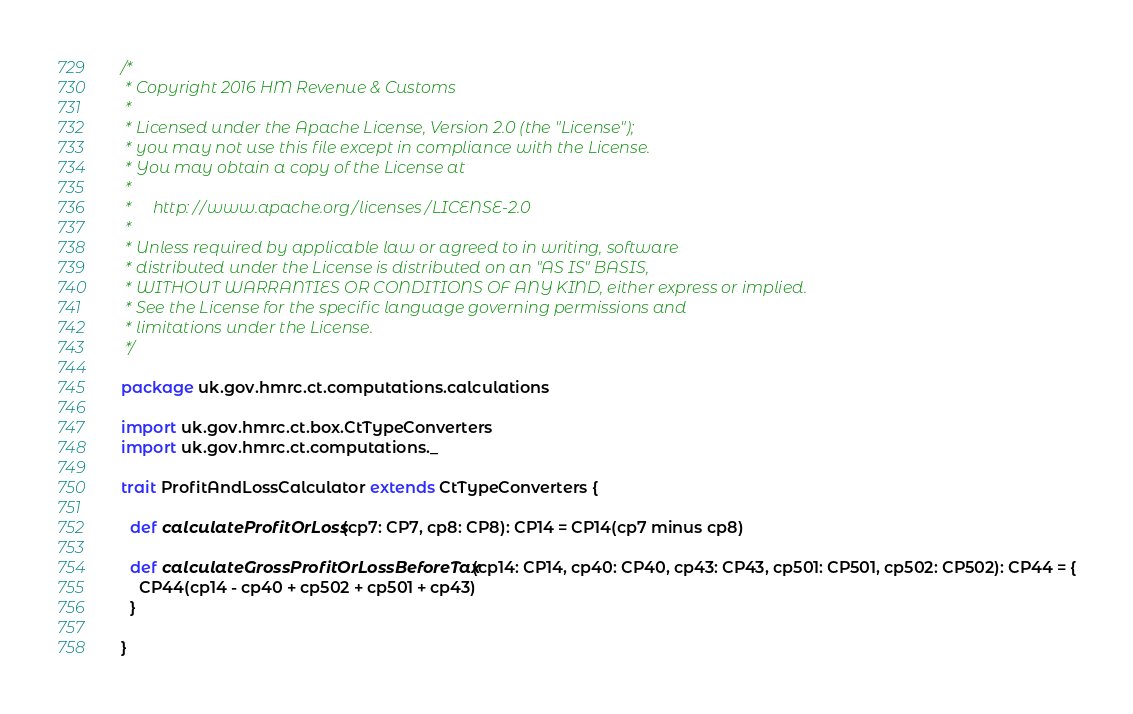<code> <loc_0><loc_0><loc_500><loc_500><_Scala_>/*
 * Copyright 2016 HM Revenue & Customs
 *
 * Licensed under the Apache License, Version 2.0 (the "License");
 * you may not use this file except in compliance with the License.
 * You may obtain a copy of the License at
 *
 *     http://www.apache.org/licenses/LICENSE-2.0
 *
 * Unless required by applicable law or agreed to in writing, software
 * distributed under the License is distributed on an "AS IS" BASIS,
 * WITHOUT WARRANTIES OR CONDITIONS OF ANY KIND, either express or implied.
 * See the License for the specific language governing permissions and
 * limitations under the License.
 */

package uk.gov.hmrc.ct.computations.calculations

import uk.gov.hmrc.ct.box.CtTypeConverters
import uk.gov.hmrc.ct.computations._

trait ProfitAndLossCalculator extends CtTypeConverters {

  def calculateProfitOrLoss(cp7: CP7, cp8: CP8): CP14 = CP14(cp7 minus cp8)

  def calculateGrossProfitOrLossBeforeTax(cp14: CP14, cp40: CP40, cp43: CP43, cp501: CP501, cp502: CP502): CP44 = {
    CP44(cp14 - cp40 + cp502 + cp501 + cp43)
  }

}
</code> 